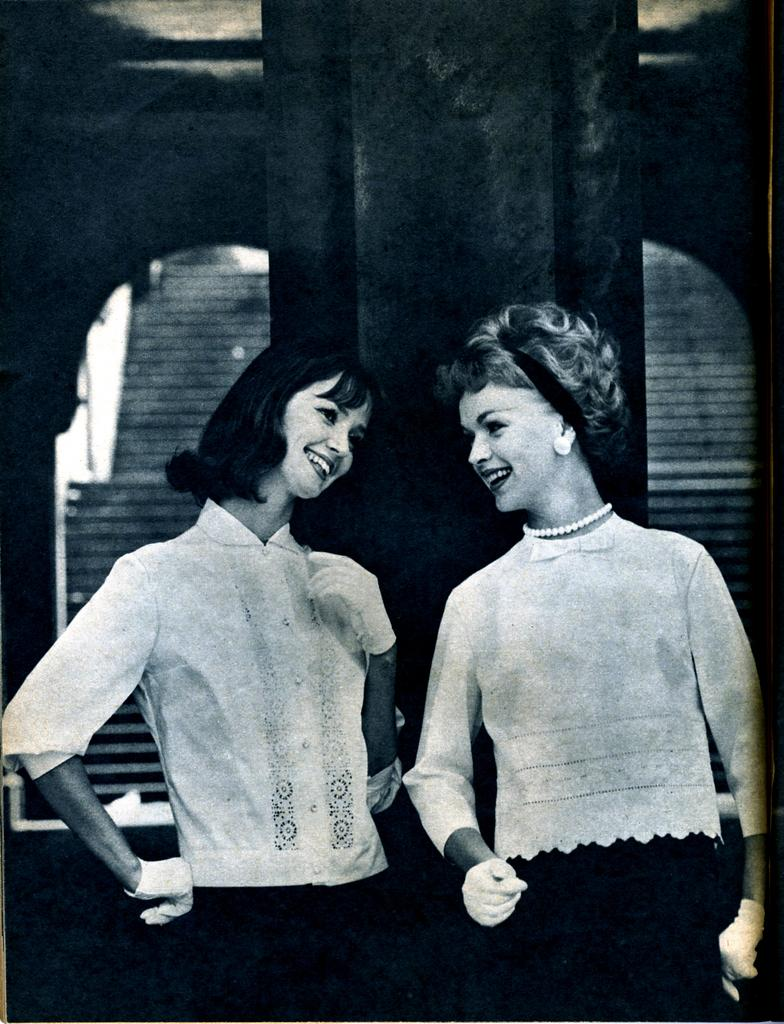What is the color scheme of the image? The image is black and white. How many women are in the picture? There are two women in the picture. What are the women wearing on their hands? The women are wearing gloves. What expression do the women have in the image? The women are smiling. What architectural features can be seen in the background of the image? There are stairs, a wall, and a pillar in the background of the image. What type of appliance can be seen in the hands of the women in the image? There is no appliance visible in the hands of the women in the image; they are wearing gloves. Can you tell me the relationship between the women and the tiger in the image? There is no tiger present in the image, so it is not possible to determine any relationship between the women and a tiger. 